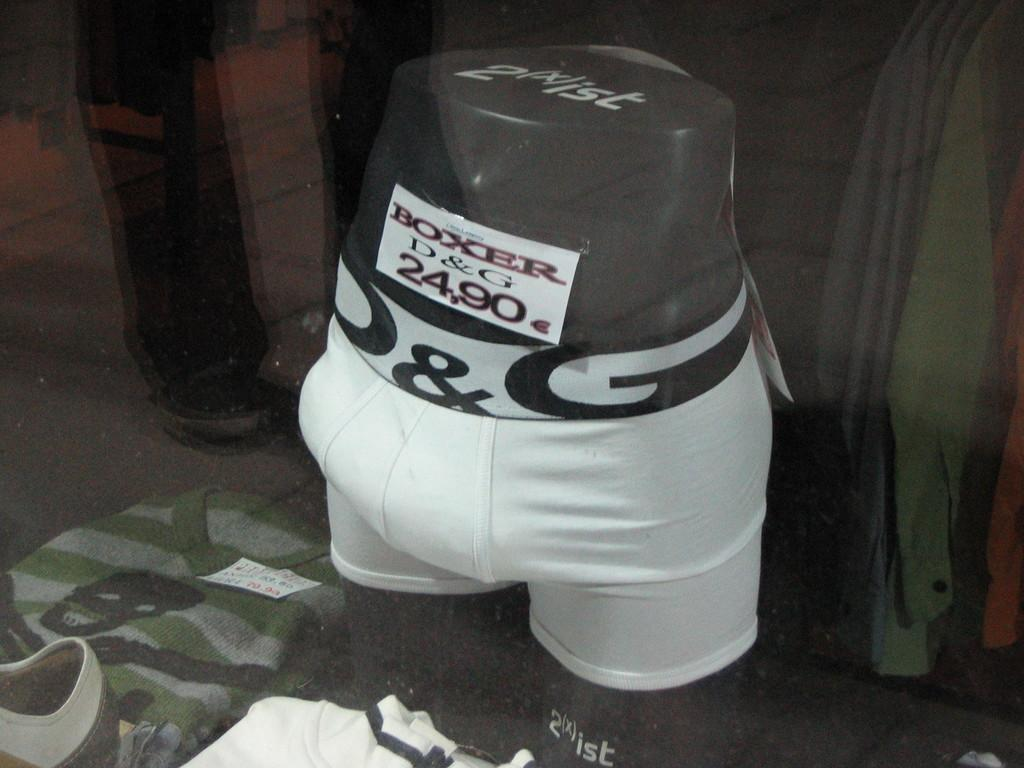What is connected to the mannequin in the image? There is a short to a mannequin in the image. What type of clothing is displayed on the mannequin? There are shirts visible around the mannequin in the image. What type of spark can be seen coming from the mannequin in the image? There is no spark visible coming from the mannequin in the image. What type of disease is the mannequin suffering from in the image? The mannequin is not a living being and therefore cannot suffer from any disease. 